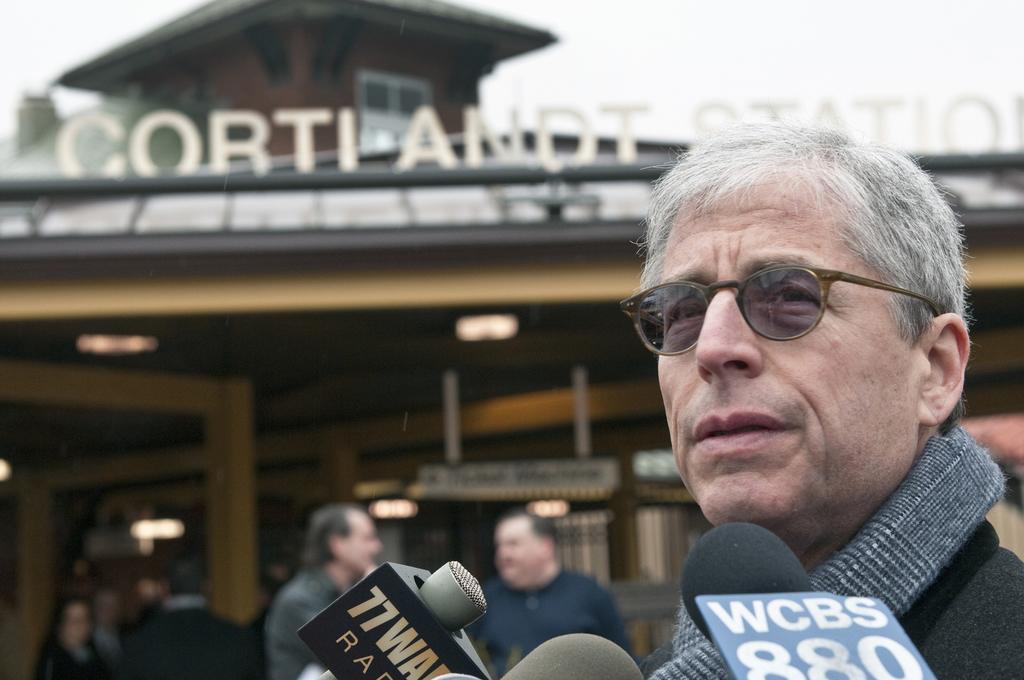Could you give a brief overview of what you see in this image? In this image we can see group of persons. At the bottom of the image we can see some microphones. In the center of the image we can see a building with some lights, window, poles and a sign board with some text. In the background, we can see the sky. 